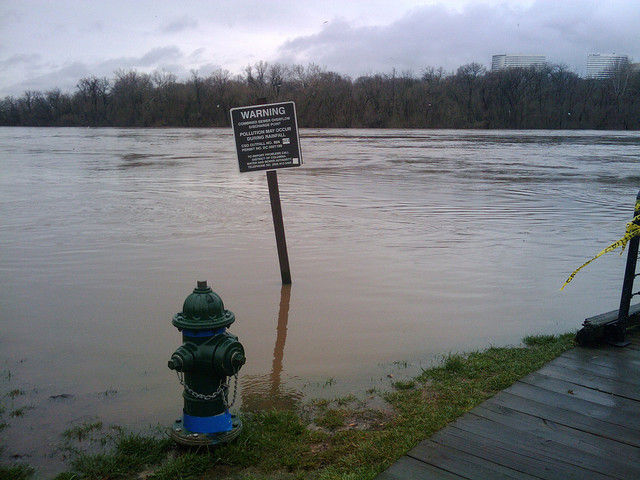Read and extract the text from this image. WARNING 